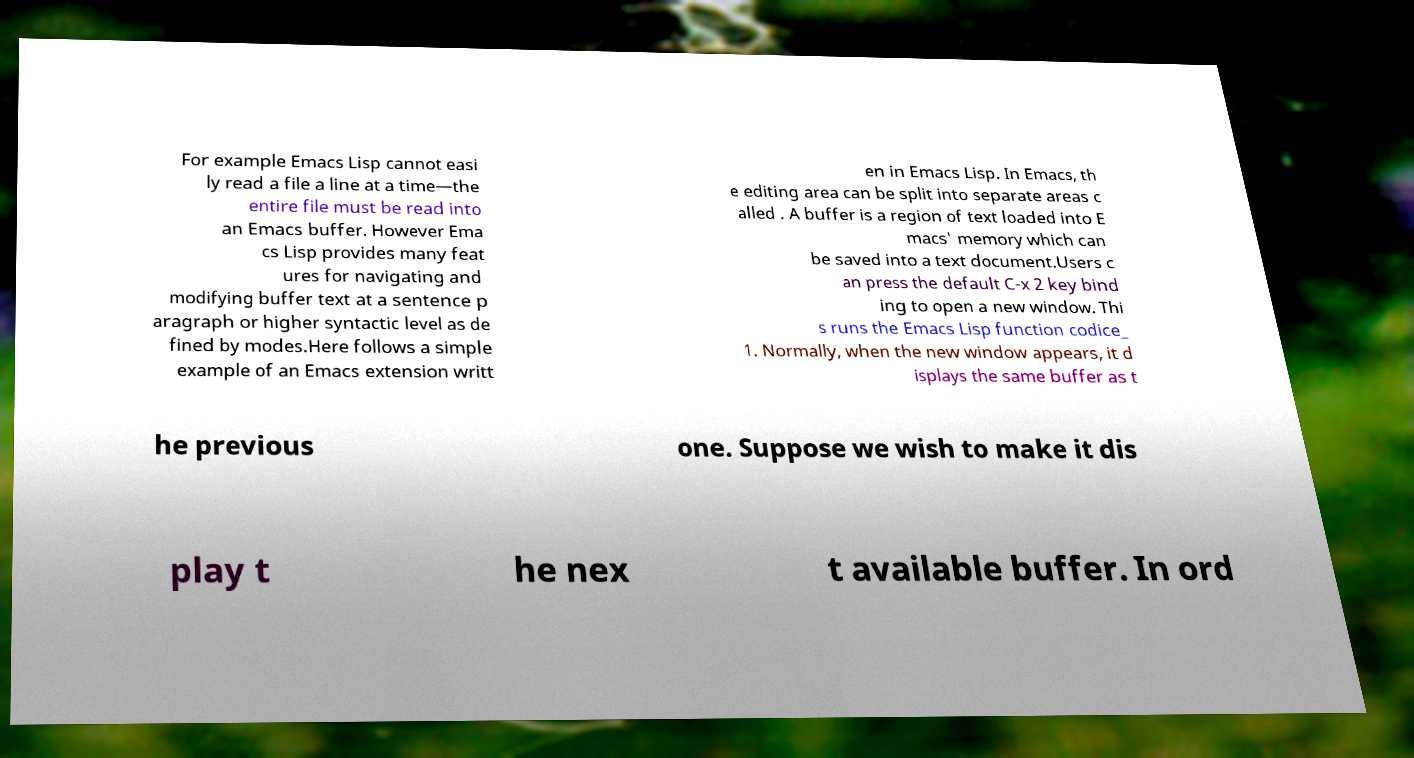Can you accurately transcribe the text from the provided image for me? For example Emacs Lisp cannot easi ly read a file a line at a time—the entire file must be read into an Emacs buffer. However Ema cs Lisp provides many feat ures for navigating and modifying buffer text at a sentence p aragraph or higher syntactic level as de fined by modes.Here follows a simple example of an Emacs extension writt en in Emacs Lisp. In Emacs, th e editing area can be split into separate areas c alled . A buffer is a region of text loaded into E macs' memory which can be saved into a text document.Users c an press the default C-x 2 key bind ing to open a new window. Thi s runs the Emacs Lisp function codice_ 1. Normally, when the new window appears, it d isplays the same buffer as t he previous one. Suppose we wish to make it dis play t he nex t available buffer. In ord 